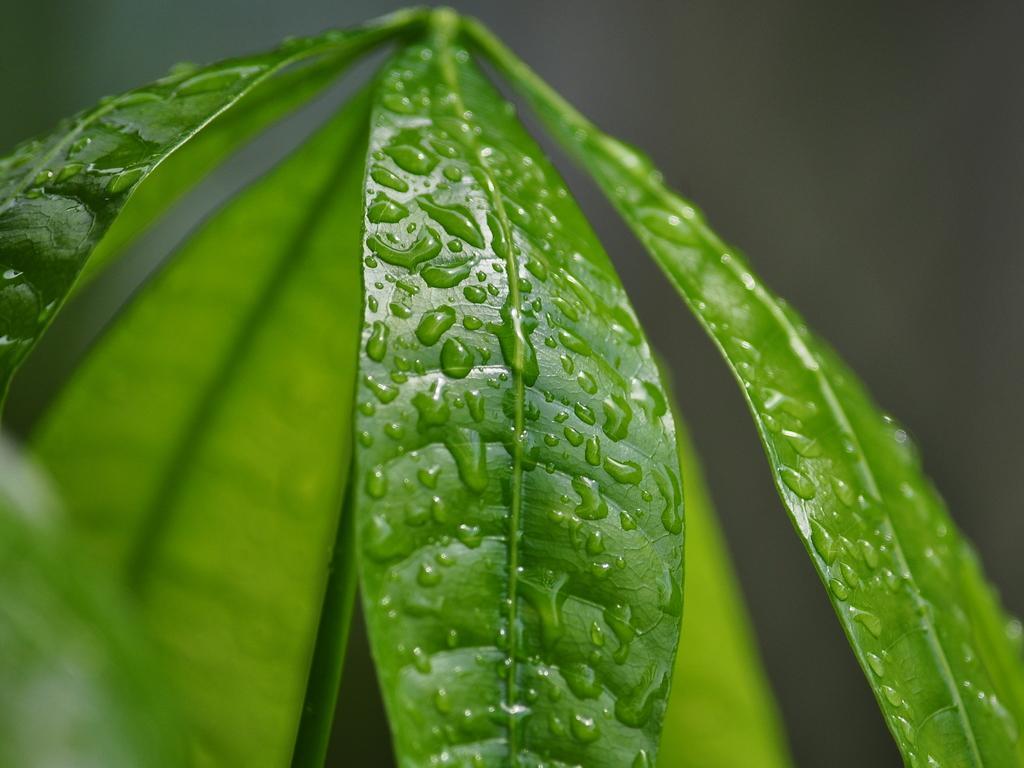In one or two sentences, can you explain what this image depicts? In the foreground of this image, there are water droplets on the leaves and the background image is blur. 